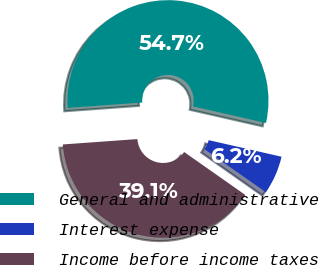Convert chart to OTSL. <chart><loc_0><loc_0><loc_500><loc_500><pie_chart><fcel>General and administrative<fcel>Interest expense<fcel>Income before income taxes<nl><fcel>54.7%<fcel>6.18%<fcel>39.11%<nl></chart> 